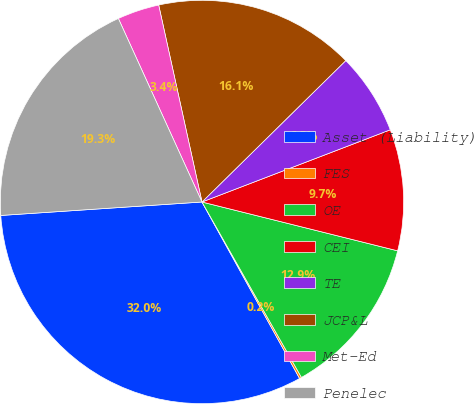<chart> <loc_0><loc_0><loc_500><loc_500><pie_chart><fcel>Asset (Liability)<fcel>FES<fcel>OE<fcel>CEI<fcel>TE<fcel>JCP&L<fcel>Met-Ed<fcel>Penelec<nl><fcel>31.98%<fcel>0.17%<fcel>12.9%<fcel>9.72%<fcel>6.54%<fcel>16.08%<fcel>3.36%<fcel>19.26%<nl></chart> 